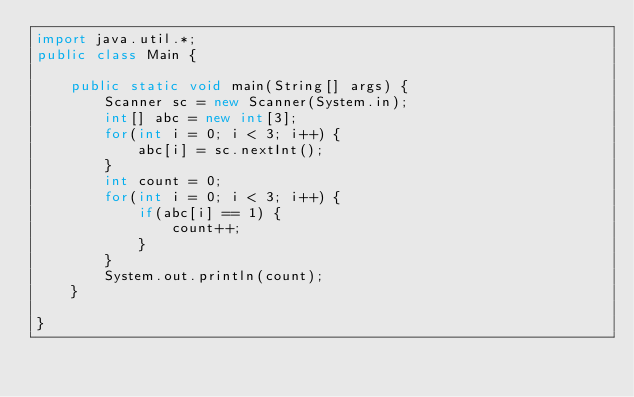<code> <loc_0><loc_0><loc_500><loc_500><_Java_>import java.util.*;
public class Main {

	public static void main(String[] args) {
		Scanner sc = new Scanner(System.in);
		int[] abc = new int[3];
		for(int i = 0; i < 3; i++) {
			abc[i] = sc.nextInt();
		}
		int count = 0;
		for(int i = 0; i < 3; i++) {
			if(abc[i] == 1) {
				count++;
			}
		}
		System.out.println(count);
	}

}
</code> 